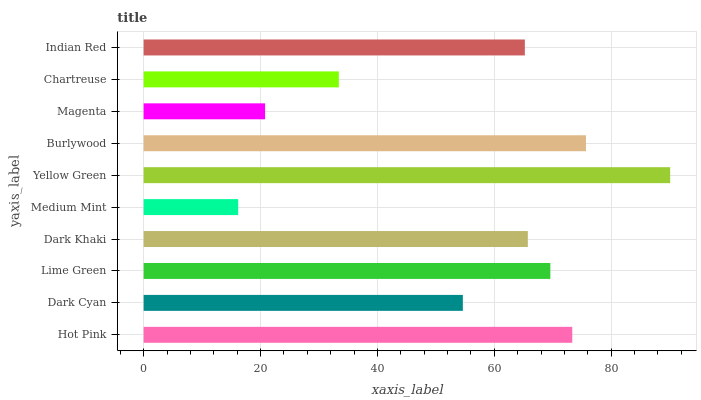Is Medium Mint the minimum?
Answer yes or no. Yes. Is Yellow Green the maximum?
Answer yes or no. Yes. Is Dark Cyan the minimum?
Answer yes or no. No. Is Dark Cyan the maximum?
Answer yes or no. No. Is Hot Pink greater than Dark Cyan?
Answer yes or no. Yes. Is Dark Cyan less than Hot Pink?
Answer yes or no. Yes. Is Dark Cyan greater than Hot Pink?
Answer yes or no. No. Is Hot Pink less than Dark Cyan?
Answer yes or no. No. Is Dark Khaki the high median?
Answer yes or no. Yes. Is Indian Red the low median?
Answer yes or no. Yes. Is Burlywood the high median?
Answer yes or no. No. Is Dark Khaki the low median?
Answer yes or no. No. 